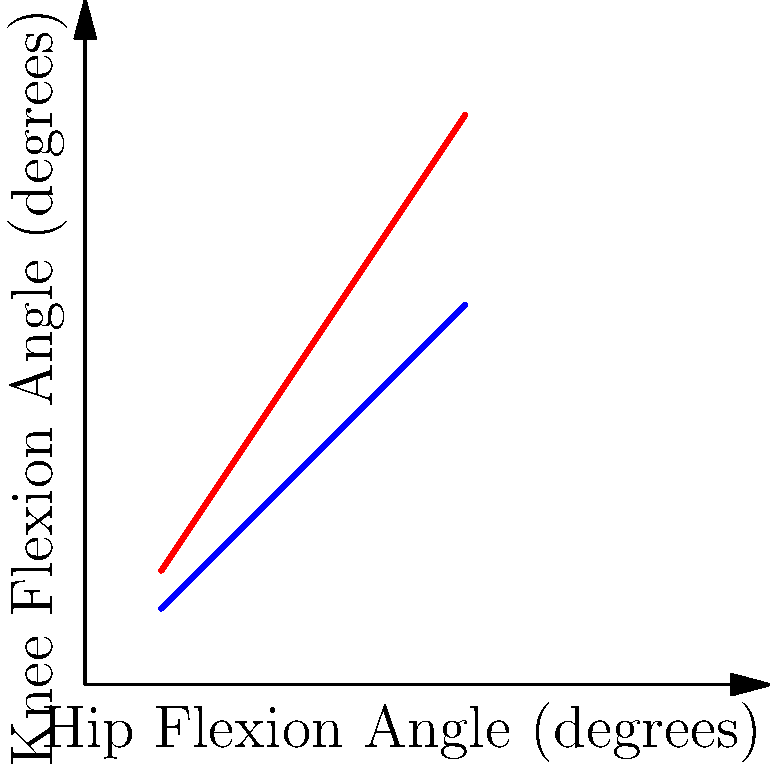In the graph above, which curve (A or B) likely represents the joint angle relationship between hip and knee flexion when dancing in a restrictive costume, and why does this curve show a more pronounced increase in knee flexion relative to hip flexion? To answer this question, let's analyze the graph step-by-step:

1. The graph shows the relationship between hip flexion angle (x-axis) and knee flexion angle (y-axis) for two different costume types.

2. Curve A (red) shows a steeper increase in knee flexion angle relative to hip flexion angle compared to Curve B (blue).

3. In a restrictive costume:
   a. Movement is limited, especially in the hip joint.
   b. To compensate for reduced hip mobility, dancers often increase knee flexion to achieve the desired leg positions.

4. In a flowing costume:
   a. Movement is less restricted, allowing for more natural joint angles.
   b. The relationship between hip and knee flexion is more balanced and proportional.

5. Curve A shows this compensation mechanism:
   a. For a given hip flexion angle, the knee flexion angle is greater compared to Curve B.
   b. This indicates that the dancer is relying more on knee movement to achieve the desired leg position.

6. Curve B represents a more balanced relationship between hip and knee flexion, typical of dancing in a flowing costume.

Therefore, Curve A likely represents the joint angle relationship when dancing in a restrictive costume, as it shows a more pronounced increase in knee flexion relative to hip flexion to compensate for limited hip mobility.
Answer: Curve A; compensates for limited hip mobility with increased knee flexion. 